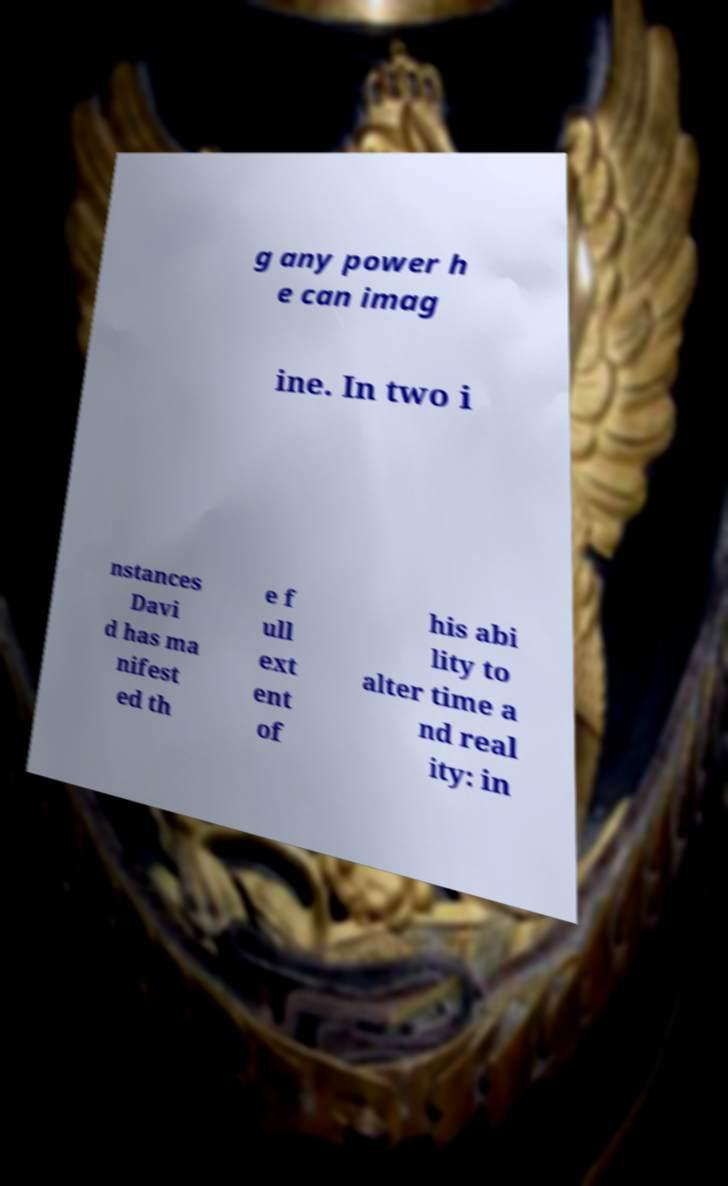Could you assist in decoding the text presented in this image and type it out clearly? g any power h e can imag ine. In two i nstances Davi d has ma nifest ed th e f ull ext ent of his abi lity to alter time a nd real ity: in 